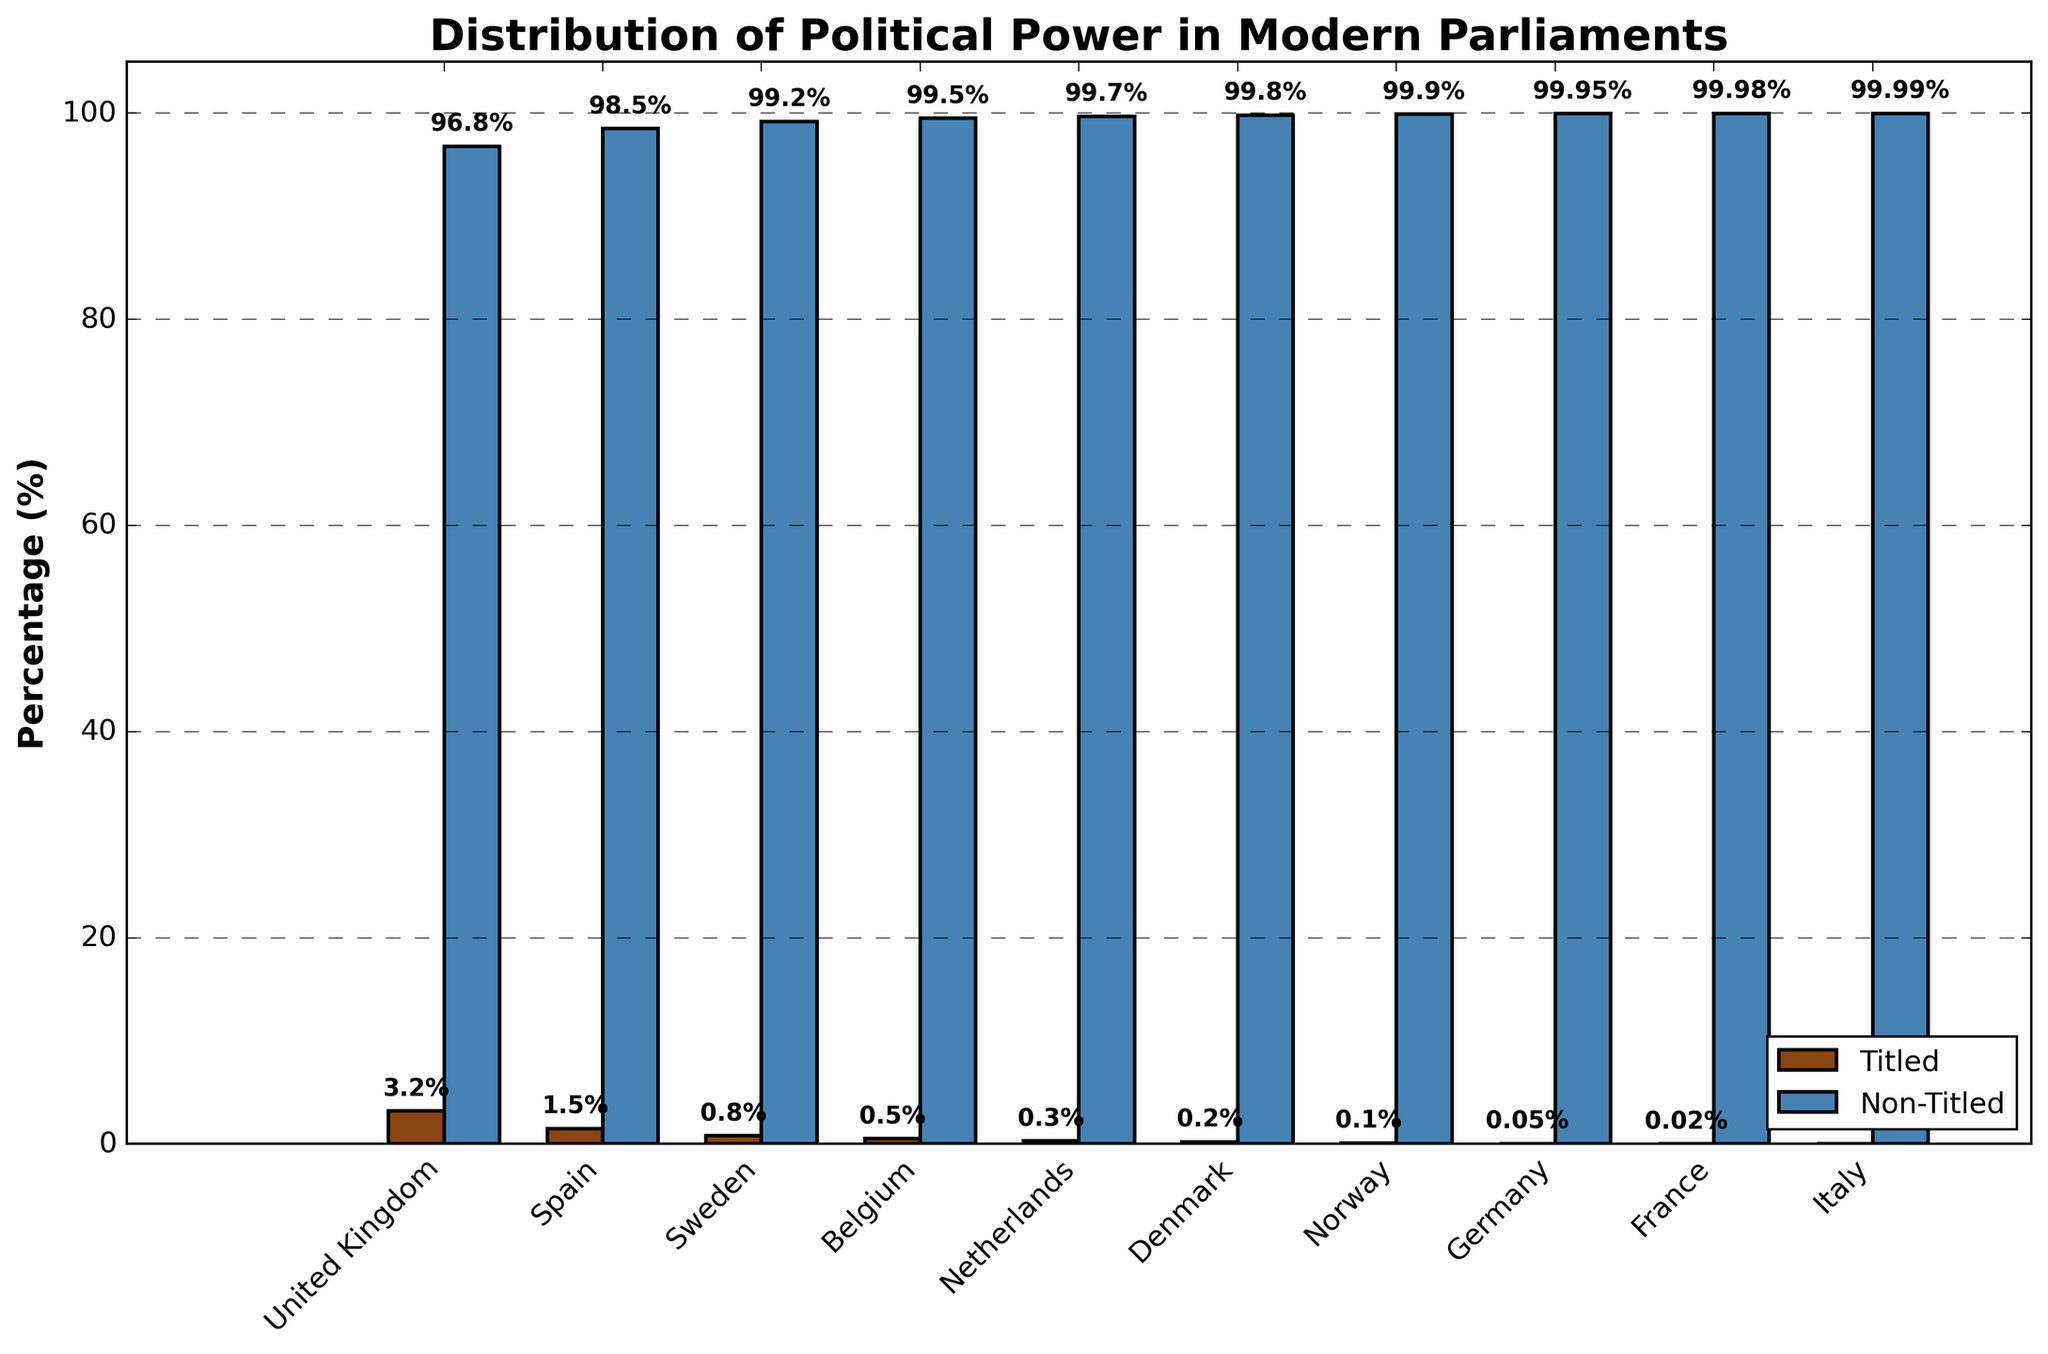Which country has the highest percentage of titled individuals in parliament? Look for the bar representing titled individuals in each country. The United Kingdom has the highest bar.
Answer: United Kingdom What is the combined percentage of titled individuals in Spain, Sweden, and Belgium? Sum the percentages of titled individuals in Spain, Sweden, and Belgium: 1.5 + 0.8 + 0.5 = 2.8%
Answer: 2.8% In which country is the percentage of non-titled individuals the lowest? Look for the shortest bar representing non-titled individuals, which is in the United Kingdom.
Answer: United Kingdom How does the percentage of titled individuals in Germany compare to that in France? Compare the heights of the bars for titled individuals in Germany and France: 0.05% in Germany and 0.02% in France.
Answer: Germany has a higher percentage Which country has nearly no titled individuals in its parliament? Look for the bar that is almost at the bottom for titled individuals, which is Italy with 0.01%.
Answer: Italy Is the percentage of non-titled individuals consistently above 99% in most countries? Check if the non-titled bars are at or above the 99% mark for each country: Most countries have non-titled bars above 99%.
Answer: Yes What is the difference in the percentage of titled individuals between the United Kingdom and Denmark? Subtract Denmark's percentage from the United Kingdom's: 3.2% - 0.2% = 3.0%.
Answer: 3.0% Which two countries have the closest percentages of titled individuals? Compare the percentages to find the smallest difference: Belgium and Netherlands (0.5% and 0.3%) have the closest percentages.
Answer: Belgium and Netherlands What is the combined percentage of non-titled individuals across all countries? Sum the percentages of non-titled individuals for all countries: 96.8 + 98.5 + 99.2 + 99.5 + 99.7 + 99.8 + 99.9 + 99.95 + 99.98 + 99.99 = 993.52.
Answer: 993.52% Which country has a titled individuals percentage of less than 0.5% but more than 0.05%? Identify the countries with titled percentages between 0.05% and 0.5%: Belgium (0.5%) is just at the threshold, so Spain (1.5%) and Sweden (0.8%) are the only options left.
Answer: None 